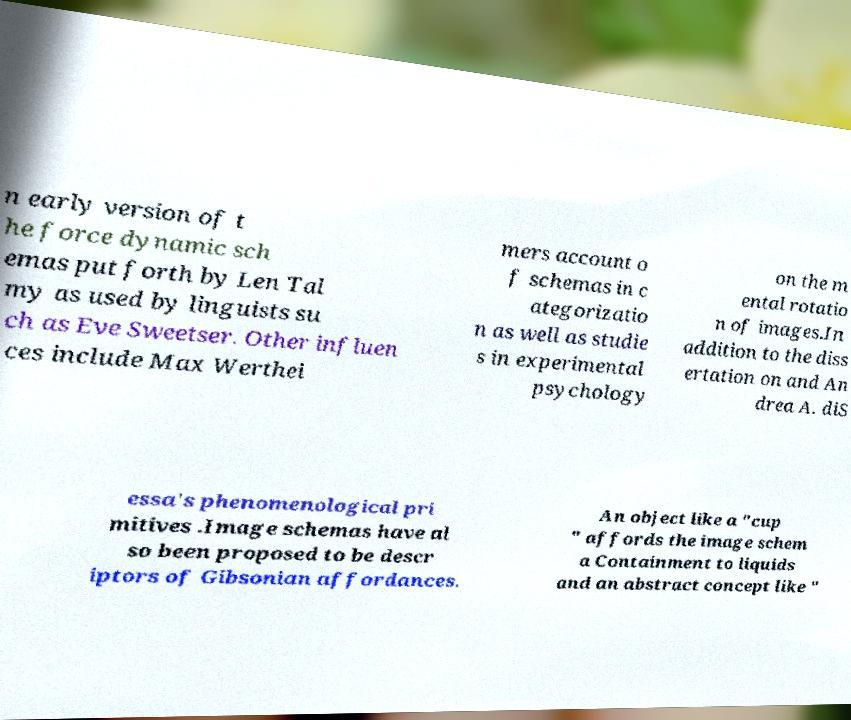Can you accurately transcribe the text from the provided image for me? n early version of t he force dynamic sch emas put forth by Len Tal my as used by linguists su ch as Eve Sweetser. Other influen ces include Max Werthei mers account o f schemas in c ategorizatio n as well as studie s in experimental psychology on the m ental rotatio n of images.In addition to the diss ertation on and An drea A. diS essa's phenomenological pri mitives .Image schemas have al so been proposed to be descr iptors of Gibsonian affordances. An object like a "cup " affords the image schem a Containment to liquids and an abstract concept like " 